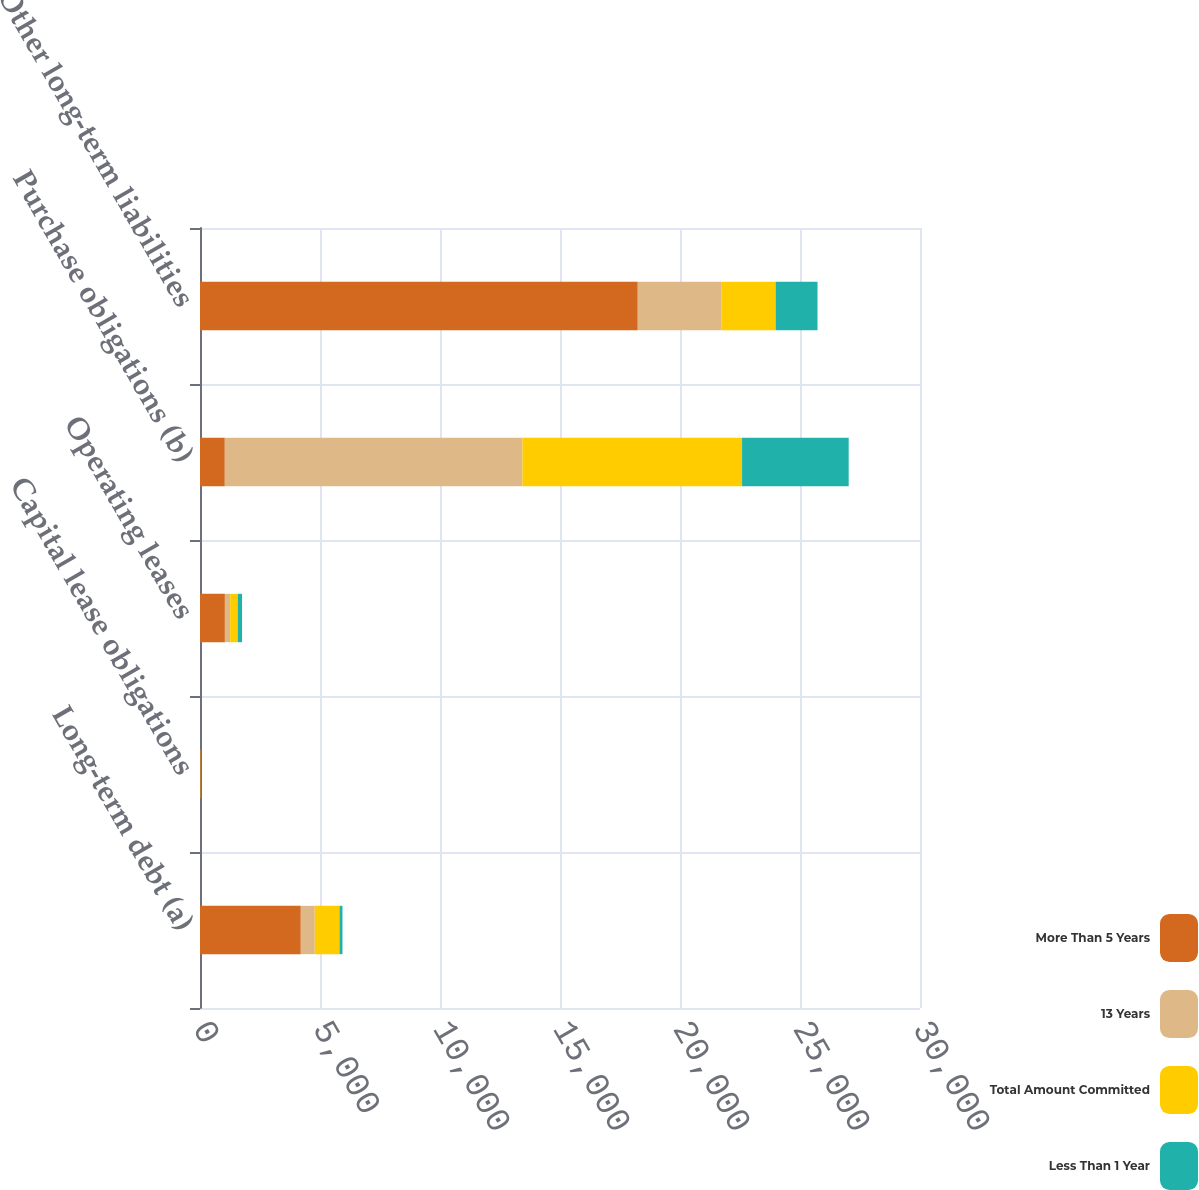<chart> <loc_0><loc_0><loc_500><loc_500><stacked_bar_chart><ecel><fcel>Long-term debt (a)<fcel>Capital lease obligations<fcel>Operating leases<fcel>Purchase obligations (b)<fcel>Other long-term liabilities<nl><fcel>More Than 5 Years<fcel>4200<fcel>32<fcel>1037<fcel>1033<fcel>18240<nl><fcel>13 Years<fcel>581<fcel>2<fcel>220<fcel>12401<fcel>3477<nl><fcel>Total Amount Committed<fcel>1033<fcel>4<fcel>315<fcel>9152<fcel>2268<nl><fcel>Less Than 1 Year<fcel>122<fcel>4<fcel>180<fcel>4443<fcel>1745<nl></chart> 